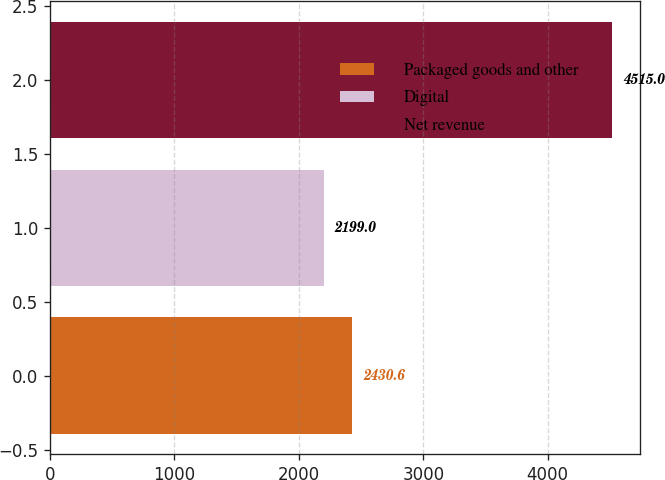Convert chart. <chart><loc_0><loc_0><loc_500><loc_500><bar_chart><fcel>Packaged goods and other<fcel>Digital<fcel>Net revenue<nl><fcel>2430.6<fcel>2199<fcel>4515<nl></chart> 